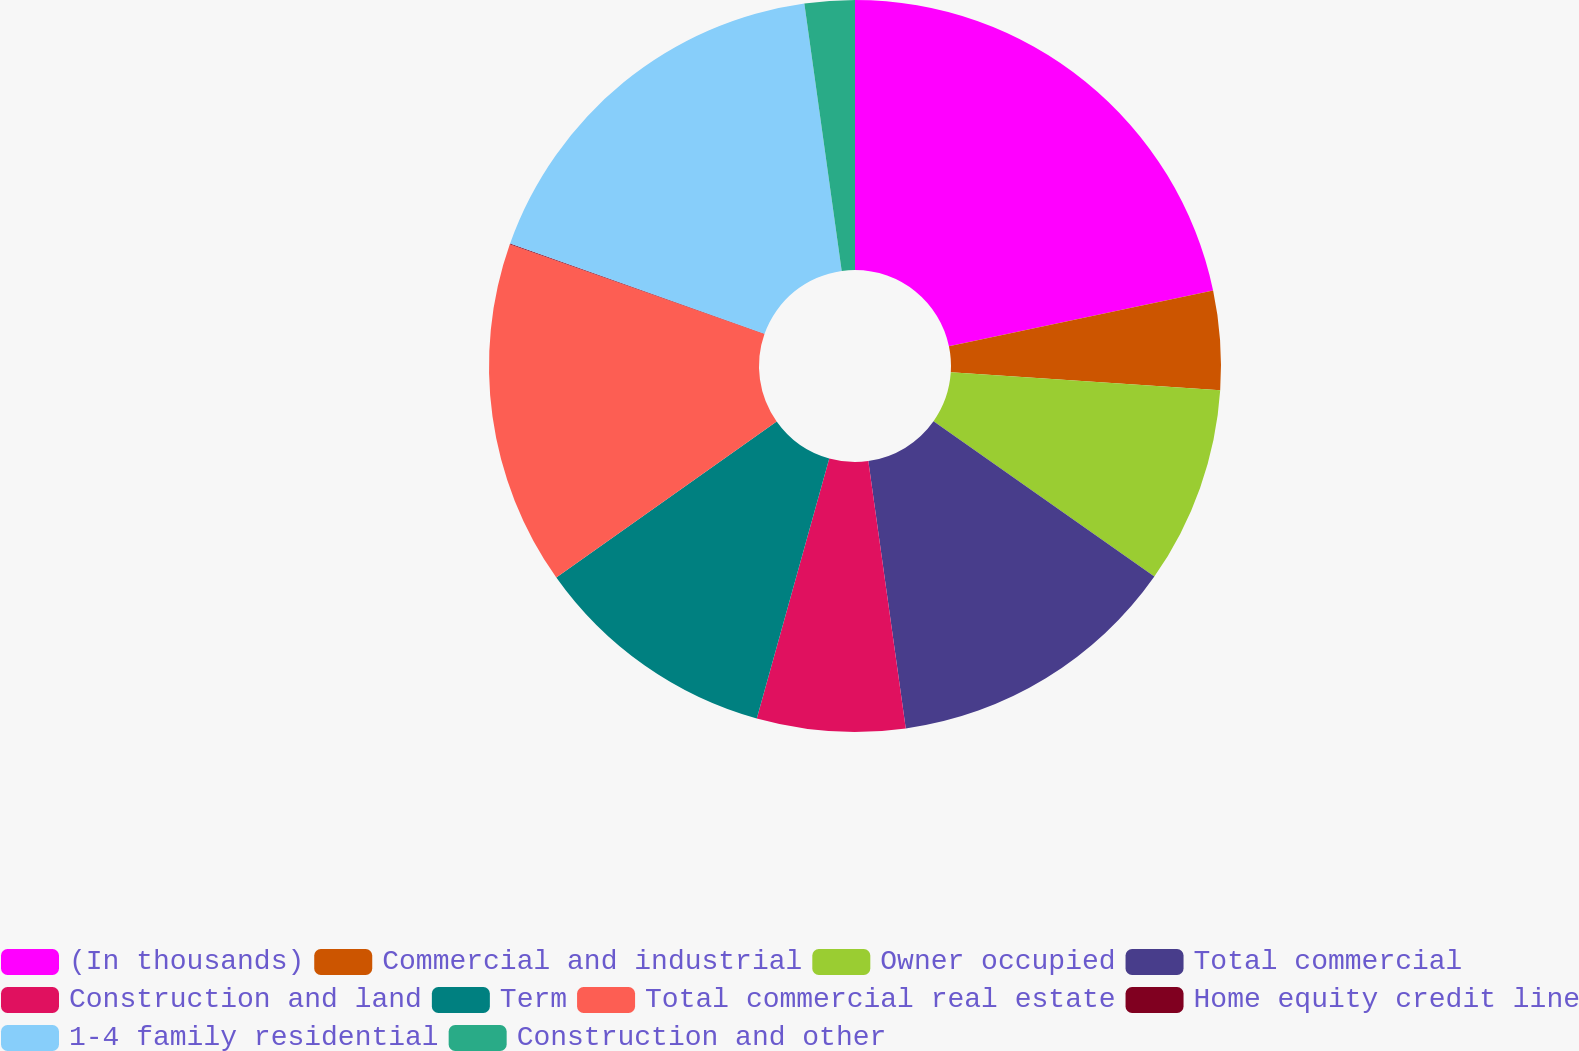Convert chart to OTSL. <chart><loc_0><loc_0><loc_500><loc_500><pie_chart><fcel>(In thousands)<fcel>Commercial and industrial<fcel>Owner occupied<fcel>Total commercial<fcel>Construction and land<fcel>Term<fcel>Total commercial real estate<fcel>Home equity credit line<fcel>1-4 family residential<fcel>Construction and other<nl><fcel>21.69%<fcel>4.37%<fcel>8.7%<fcel>13.03%<fcel>6.54%<fcel>10.87%<fcel>15.2%<fcel>0.04%<fcel>17.36%<fcel>2.21%<nl></chart> 